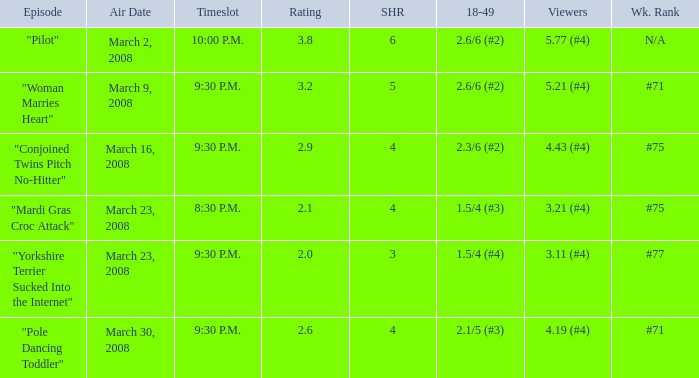What is the total ratings on share less than 4? 1.0. 